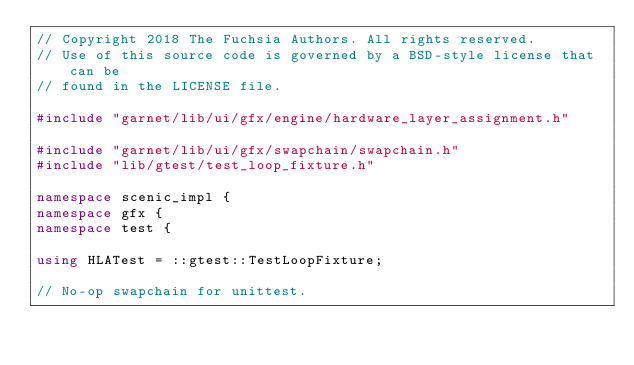<code> <loc_0><loc_0><loc_500><loc_500><_C++_>// Copyright 2018 The Fuchsia Authors. All rights reserved.
// Use of this source code is governed by a BSD-style license that can be
// found in the LICENSE file.

#include "garnet/lib/ui/gfx/engine/hardware_layer_assignment.h"

#include "garnet/lib/ui/gfx/swapchain/swapchain.h"
#include "lib/gtest/test_loop_fixture.h"

namespace scenic_impl {
namespace gfx {
namespace test {

using HLATest = ::gtest::TestLoopFixture;

// No-op swapchain for unittest.</code> 